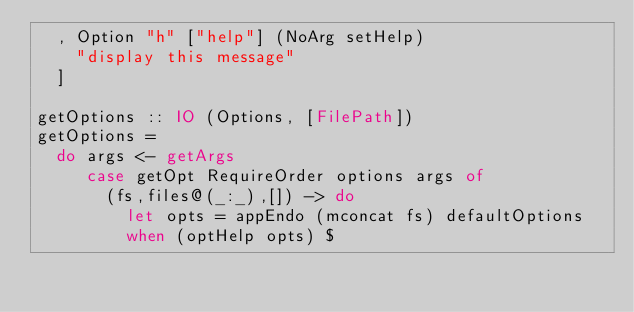<code> <loc_0><loc_0><loc_500><loc_500><_Haskell_>  , Option "h" ["help"] (NoArg setHelp)
    "display this message"
  ]

getOptions :: IO (Options, [FilePath])
getOptions =
  do args <- getArgs
     case getOpt RequireOrder options args of
       (fs,files@(_:_),[]) -> do
         let opts = appEndo (mconcat fs) defaultOptions
         when (optHelp opts) $</code> 